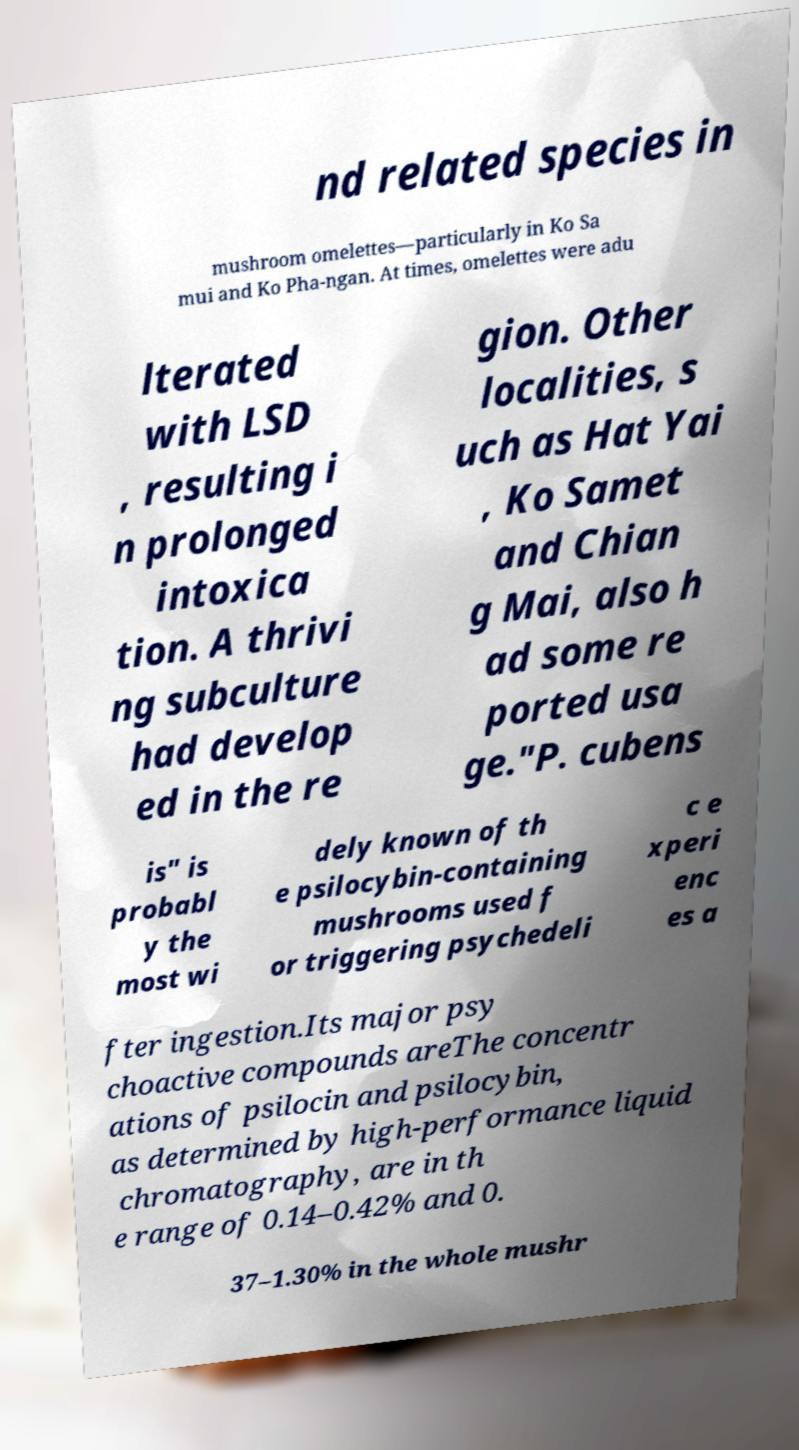For documentation purposes, I need the text within this image transcribed. Could you provide that? nd related species in mushroom omelettes—particularly in Ko Sa mui and Ko Pha-ngan. At times, omelettes were adu lterated with LSD , resulting i n prolonged intoxica tion. A thrivi ng subculture had develop ed in the re gion. Other localities, s uch as Hat Yai , Ko Samet and Chian g Mai, also h ad some re ported usa ge."P. cubens is" is probabl y the most wi dely known of th e psilocybin-containing mushrooms used f or triggering psychedeli c e xperi enc es a fter ingestion.Its major psy choactive compounds areThe concentr ations of psilocin and psilocybin, as determined by high-performance liquid chromatography, are in th e range of 0.14–0.42% and 0. 37–1.30% in the whole mushr 